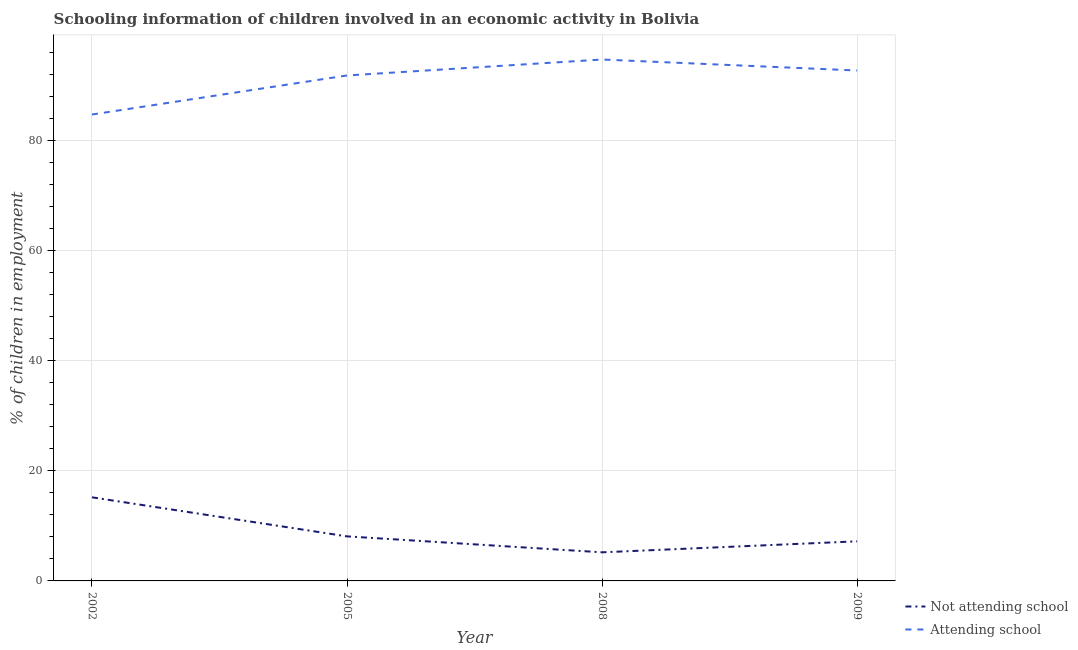Across all years, what is the maximum percentage of employed children who are not attending school?
Provide a short and direct response. 15.2. Across all years, what is the minimum percentage of employed children who are attending school?
Provide a succinct answer. 84.8. In which year was the percentage of employed children who are not attending school maximum?
Offer a very short reply. 2002. What is the total percentage of employed children who are not attending school in the graph?
Give a very brief answer. 35.7. What is the difference between the percentage of employed children who are not attending school in 2002 and that in 2008?
Your response must be concise. 10. What is the difference between the percentage of employed children who are attending school in 2009 and the percentage of employed children who are not attending school in 2002?
Your response must be concise. 77.6. What is the average percentage of employed children who are not attending school per year?
Provide a short and direct response. 8.92. In the year 2005, what is the difference between the percentage of employed children who are attending school and percentage of employed children who are not attending school?
Provide a succinct answer. 83.8. What is the ratio of the percentage of employed children who are attending school in 2005 to that in 2009?
Your answer should be very brief. 0.99. Is the percentage of employed children who are attending school in 2002 less than that in 2009?
Ensure brevity in your answer.  Yes. Is the difference between the percentage of employed children who are attending school in 2005 and 2008 greater than the difference between the percentage of employed children who are not attending school in 2005 and 2008?
Your answer should be very brief. No. Does the percentage of employed children who are attending school monotonically increase over the years?
Offer a very short reply. No. Does the graph contain grids?
Offer a very short reply. Yes. Where does the legend appear in the graph?
Offer a terse response. Bottom right. What is the title of the graph?
Provide a succinct answer. Schooling information of children involved in an economic activity in Bolivia. What is the label or title of the X-axis?
Your answer should be very brief. Year. What is the label or title of the Y-axis?
Your answer should be compact. % of children in employment. What is the % of children in employment of Not attending school in 2002?
Your answer should be very brief. 15.2. What is the % of children in employment in Attending school in 2002?
Give a very brief answer. 84.8. What is the % of children in employment in Not attending school in 2005?
Make the answer very short. 8.1. What is the % of children in employment in Attending school in 2005?
Provide a succinct answer. 91.9. What is the % of children in employment in Not attending school in 2008?
Your response must be concise. 5.2. What is the % of children in employment of Attending school in 2008?
Provide a short and direct response. 94.8. What is the % of children in employment in Not attending school in 2009?
Ensure brevity in your answer.  7.2. What is the % of children in employment of Attending school in 2009?
Your answer should be very brief. 92.8. Across all years, what is the maximum % of children in employment in Attending school?
Your answer should be very brief. 94.8. Across all years, what is the minimum % of children in employment in Not attending school?
Provide a succinct answer. 5.2. Across all years, what is the minimum % of children in employment of Attending school?
Your answer should be compact. 84.8. What is the total % of children in employment of Not attending school in the graph?
Your answer should be compact. 35.7. What is the total % of children in employment of Attending school in the graph?
Offer a terse response. 364.3. What is the difference between the % of children in employment of Not attending school in 2002 and that in 2005?
Your response must be concise. 7.1. What is the difference between the % of children in employment of Not attending school in 2005 and that in 2008?
Provide a succinct answer. 2.9. What is the difference between the % of children in employment in Not attending school in 2005 and that in 2009?
Offer a terse response. 0.9. What is the difference between the % of children in employment in Attending school in 2005 and that in 2009?
Provide a succinct answer. -0.9. What is the difference between the % of children in employment in Not attending school in 2008 and that in 2009?
Your answer should be compact. -2. What is the difference between the % of children in employment in Attending school in 2008 and that in 2009?
Your answer should be very brief. 2. What is the difference between the % of children in employment of Not attending school in 2002 and the % of children in employment of Attending school in 2005?
Your answer should be compact. -76.7. What is the difference between the % of children in employment of Not attending school in 2002 and the % of children in employment of Attending school in 2008?
Your response must be concise. -79.6. What is the difference between the % of children in employment of Not attending school in 2002 and the % of children in employment of Attending school in 2009?
Provide a succinct answer. -77.6. What is the difference between the % of children in employment in Not attending school in 2005 and the % of children in employment in Attending school in 2008?
Provide a succinct answer. -86.7. What is the difference between the % of children in employment of Not attending school in 2005 and the % of children in employment of Attending school in 2009?
Provide a succinct answer. -84.7. What is the difference between the % of children in employment of Not attending school in 2008 and the % of children in employment of Attending school in 2009?
Offer a terse response. -87.6. What is the average % of children in employment in Not attending school per year?
Offer a very short reply. 8.93. What is the average % of children in employment in Attending school per year?
Your answer should be compact. 91.08. In the year 2002, what is the difference between the % of children in employment of Not attending school and % of children in employment of Attending school?
Keep it short and to the point. -69.6. In the year 2005, what is the difference between the % of children in employment in Not attending school and % of children in employment in Attending school?
Ensure brevity in your answer.  -83.8. In the year 2008, what is the difference between the % of children in employment of Not attending school and % of children in employment of Attending school?
Provide a succinct answer. -89.6. In the year 2009, what is the difference between the % of children in employment of Not attending school and % of children in employment of Attending school?
Ensure brevity in your answer.  -85.6. What is the ratio of the % of children in employment in Not attending school in 2002 to that in 2005?
Your answer should be very brief. 1.88. What is the ratio of the % of children in employment in Attending school in 2002 to that in 2005?
Keep it short and to the point. 0.92. What is the ratio of the % of children in employment in Not attending school in 2002 to that in 2008?
Make the answer very short. 2.92. What is the ratio of the % of children in employment in Attending school in 2002 to that in 2008?
Keep it short and to the point. 0.89. What is the ratio of the % of children in employment of Not attending school in 2002 to that in 2009?
Provide a short and direct response. 2.11. What is the ratio of the % of children in employment of Attending school in 2002 to that in 2009?
Your response must be concise. 0.91. What is the ratio of the % of children in employment in Not attending school in 2005 to that in 2008?
Your response must be concise. 1.56. What is the ratio of the % of children in employment in Attending school in 2005 to that in 2008?
Offer a terse response. 0.97. What is the ratio of the % of children in employment of Attending school in 2005 to that in 2009?
Offer a very short reply. 0.99. What is the ratio of the % of children in employment of Not attending school in 2008 to that in 2009?
Your answer should be compact. 0.72. What is the ratio of the % of children in employment in Attending school in 2008 to that in 2009?
Make the answer very short. 1.02. What is the difference between the highest and the second highest % of children in employment in Not attending school?
Make the answer very short. 7.1. 